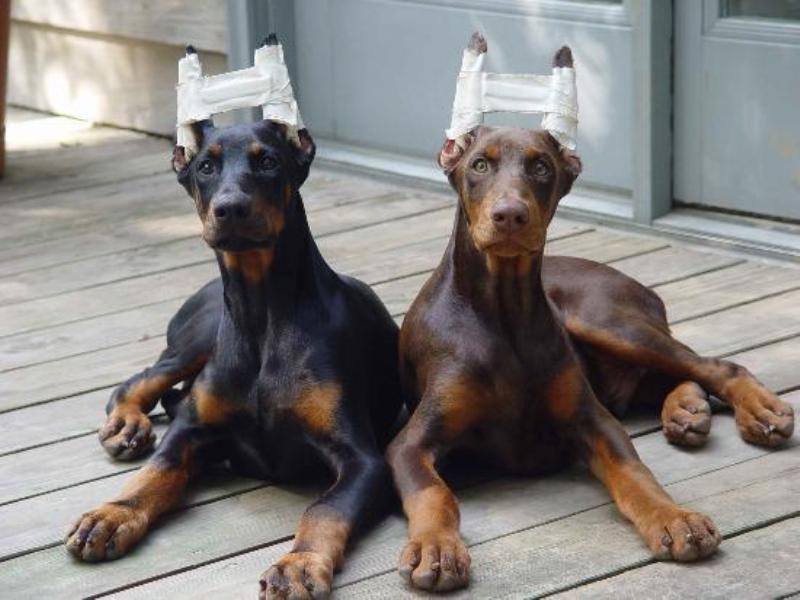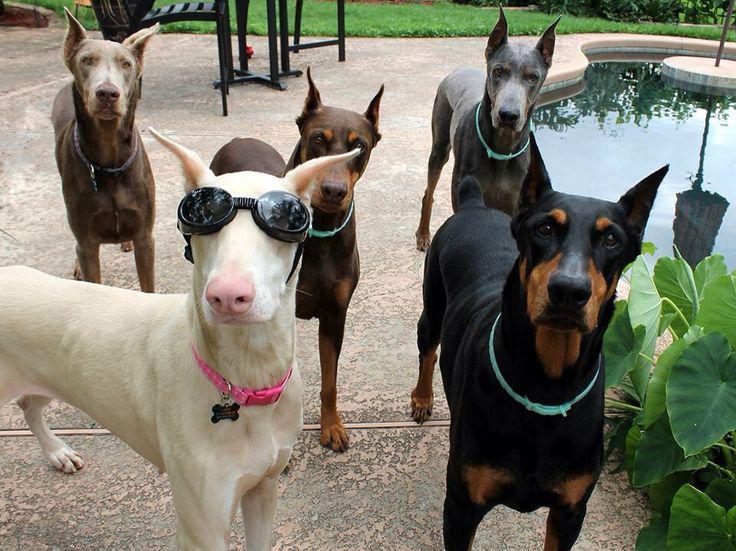The first image is the image on the left, the second image is the image on the right. Considering the images on both sides, is "A dog is laying down." valid? Answer yes or no. Yes. The first image is the image on the left, the second image is the image on the right. For the images shown, is this caption "There are only 2 dogs." true? Answer yes or no. No. 